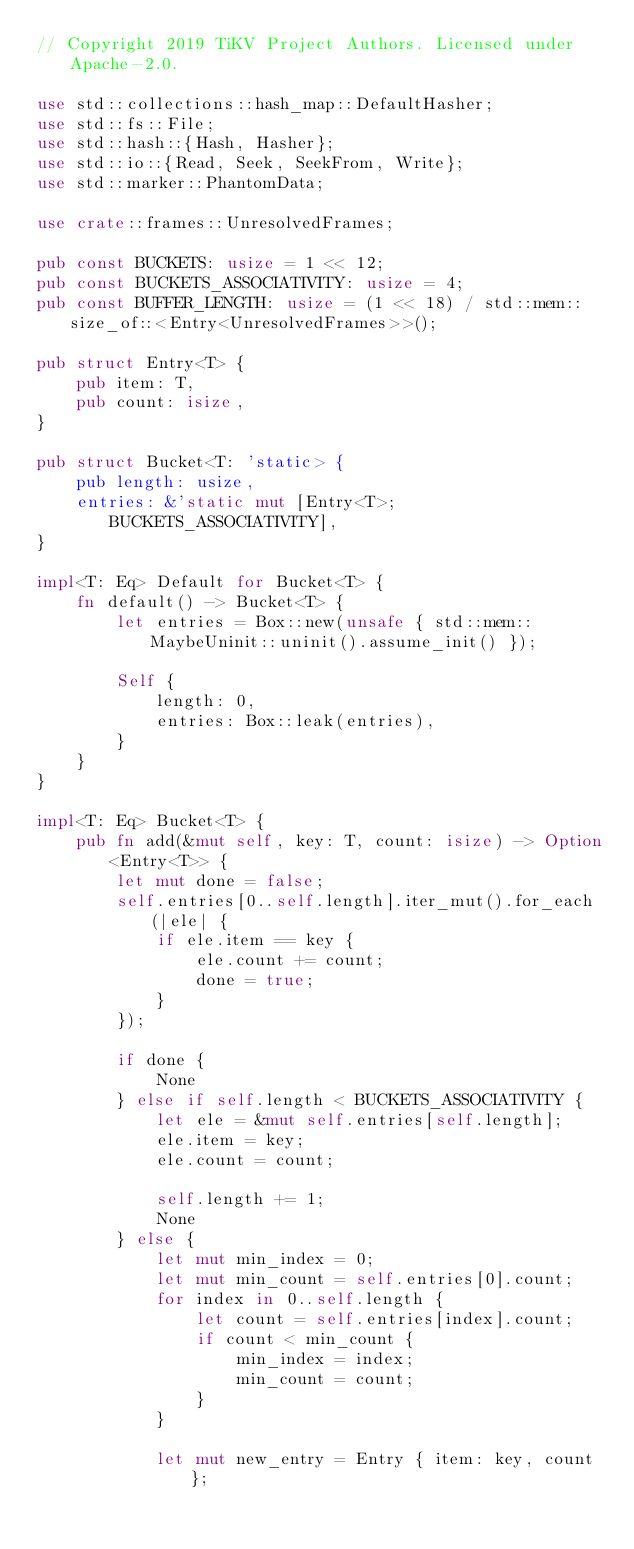<code> <loc_0><loc_0><loc_500><loc_500><_Rust_>// Copyright 2019 TiKV Project Authors. Licensed under Apache-2.0.

use std::collections::hash_map::DefaultHasher;
use std::fs::File;
use std::hash::{Hash, Hasher};
use std::io::{Read, Seek, SeekFrom, Write};
use std::marker::PhantomData;

use crate::frames::UnresolvedFrames;

pub const BUCKETS: usize = 1 << 12;
pub const BUCKETS_ASSOCIATIVITY: usize = 4;
pub const BUFFER_LENGTH: usize = (1 << 18) / std::mem::size_of::<Entry<UnresolvedFrames>>();

pub struct Entry<T> {
    pub item: T,
    pub count: isize,
}

pub struct Bucket<T: 'static> {
    pub length: usize,
    entries: &'static mut [Entry<T>; BUCKETS_ASSOCIATIVITY],
}

impl<T: Eq> Default for Bucket<T> {
    fn default() -> Bucket<T> {
        let entries = Box::new(unsafe { std::mem::MaybeUninit::uninit().assume_init() });

        Self {
            length: 0,
            entries: Box::leak(entries),
        }
    }
}

impl<T: Eq> Bucket<T> {
    pub fn add(&mut self, key: T, count: isize) -> Option<Entry<T>> {
        let mut done = false;
        self.entries[0..self.length].iter_mut().for_each(|ele| {
            if ele.item == key {
                ele.count += count;
                done = true;
            }
        });

        if done {
            None
        } else if self.length < BUCKETS_ASSOCIATIVITY {
            let ele = &mut self.entries[self.length];
            ele.item = key;
            ele.count = count;

            self.length += 1;
            None
        } else {
            let mut min_index = 0;
            let mut min_count = self.entries[0].count;
            for index in 0..self.length {
                let count = self.entries[index].count;
                if count < min_count {
                    min_index = index;
                    min_count = count;
                }
            }

            let mut new_entry = Entry { item: key, count };</code> 